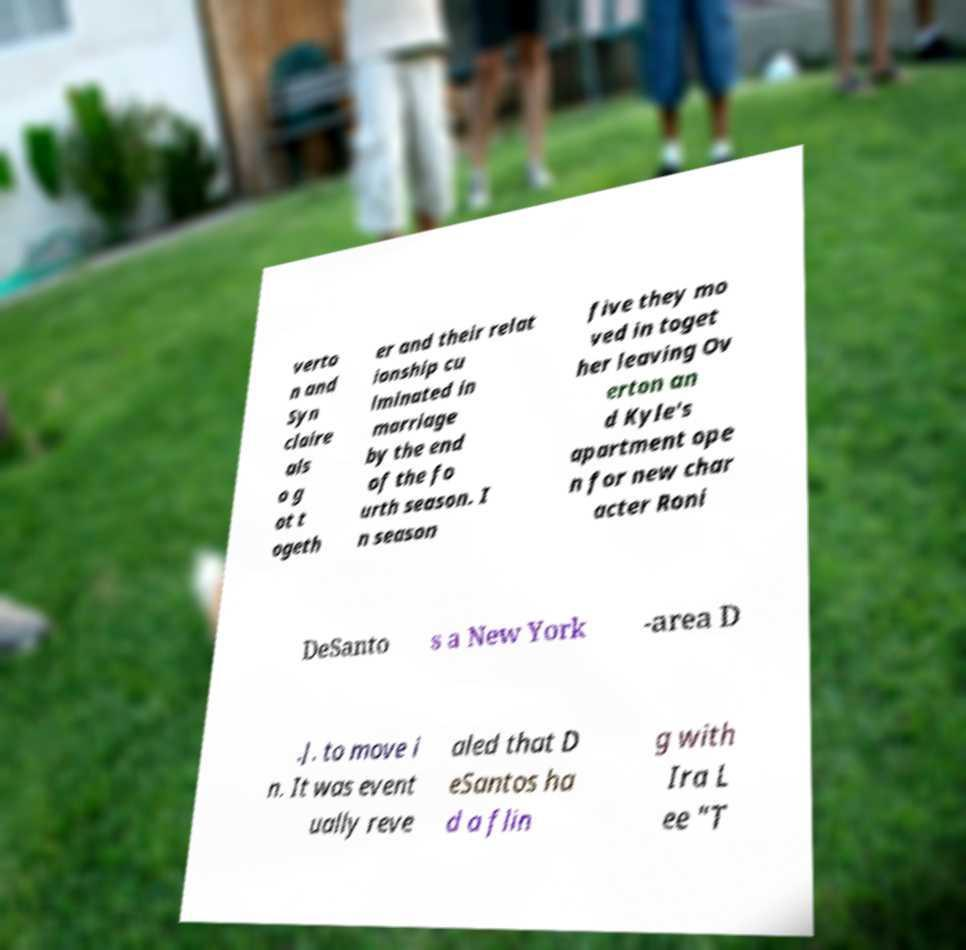Please identify and transcribe the text found in this image. verto n and Syn claire als o g ot t ogeth er and their relat ionship cu lminated in marriage by the end of the fo urth season. I n season five they mo ved in toget her leaving Ov erton an d Kyle's apartment ope n for new char acter Roni DeSanto s a New York -area D .J. to move i n. It was event ually reve aled that D eSantos ha d a flin g with Ira L ee "T 